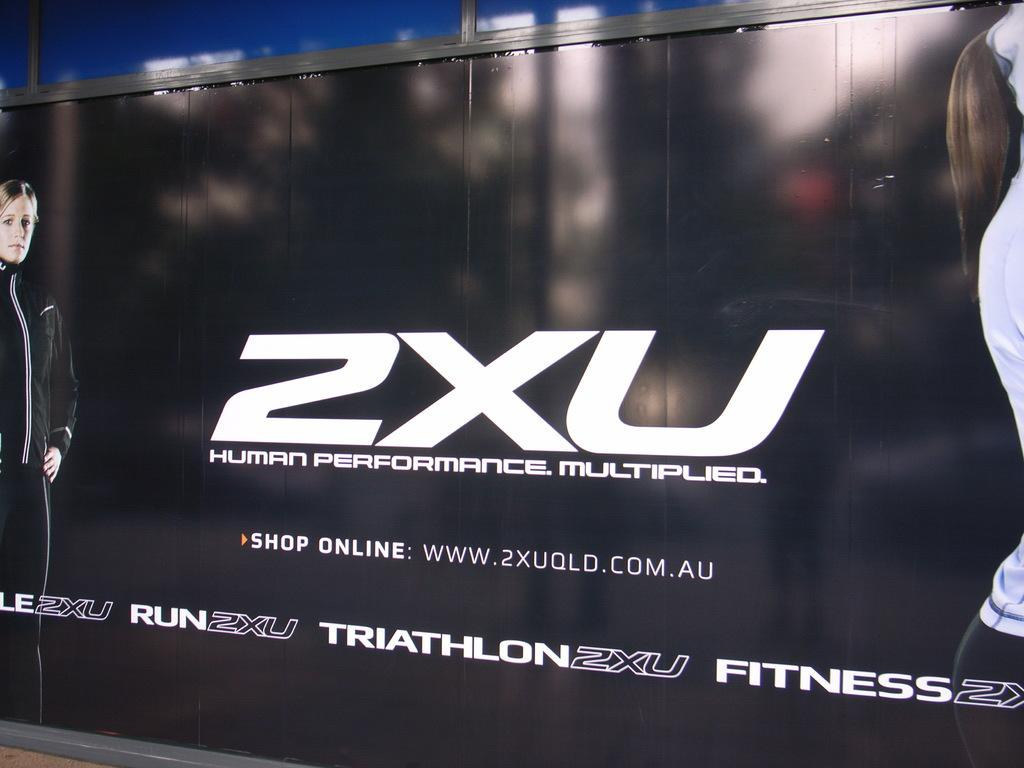<image>
Relay a brief, clear account of the picture shown. An advert for 2XU: Human Performance Multiplied printed on a wall. 